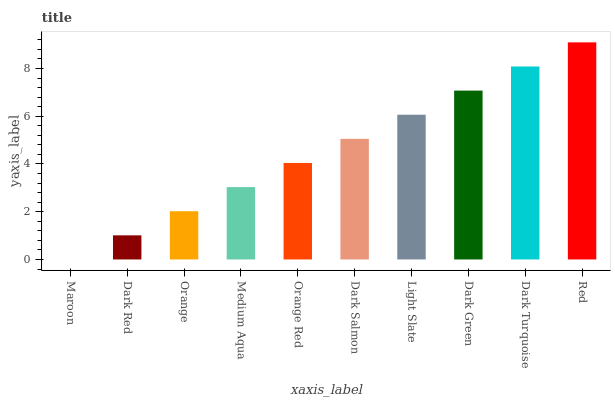Is Dark Red the minimum?
Answer yes or no. No. Is Dark Red the maximum?
Answer yes or no. No. Is Dark Red greater than Maroon?
Answer yes or no. Yes. Is Maroon less than Dark Red?
Answer yes or no. Yes. Is Maroon greater than Dark Red?
Answer yes or no. No. Is Dark Red less than Maroon?
Answer yes or no. No. Is Dark Salmon the high median?
Answer yes or no. Yes. Is Orange Red the low median?
Answer yes or no. Yes. Is Dark Red the high median?
Answer yes or no. No. Is Light Slate the low median?
Answer yes or no. No. 